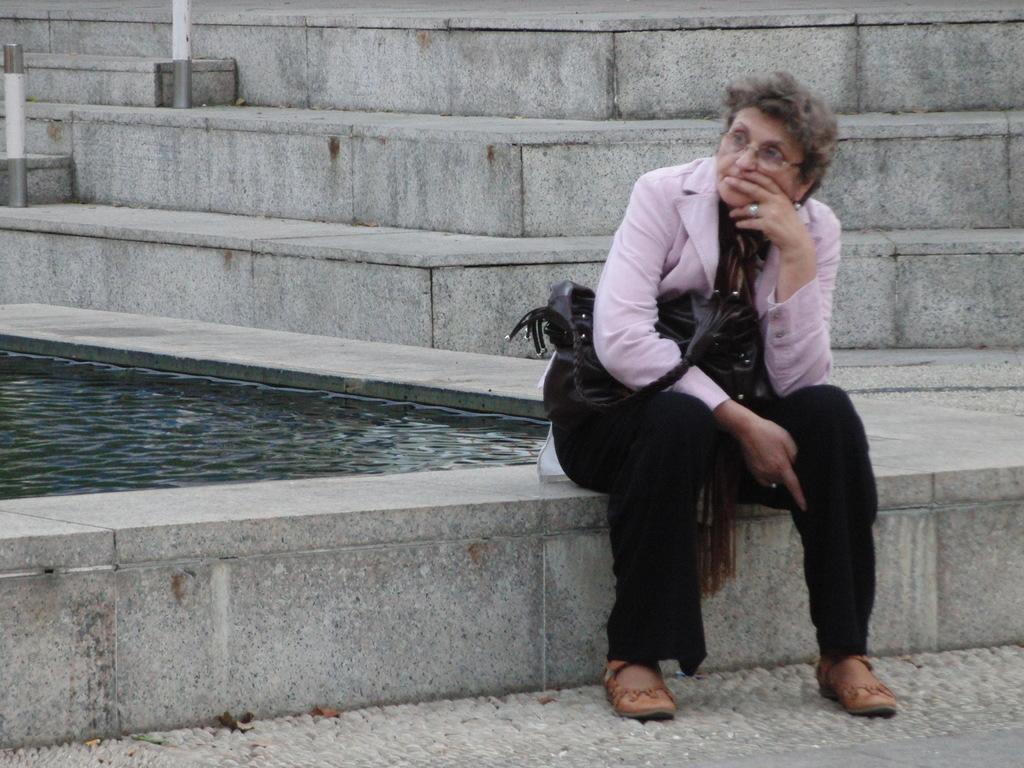How would you summarize this image in a sentence or two? In this picture we can see a woman sitting in the front and thinking something. Behind there is a small water pool. In the background we can see some steps. 